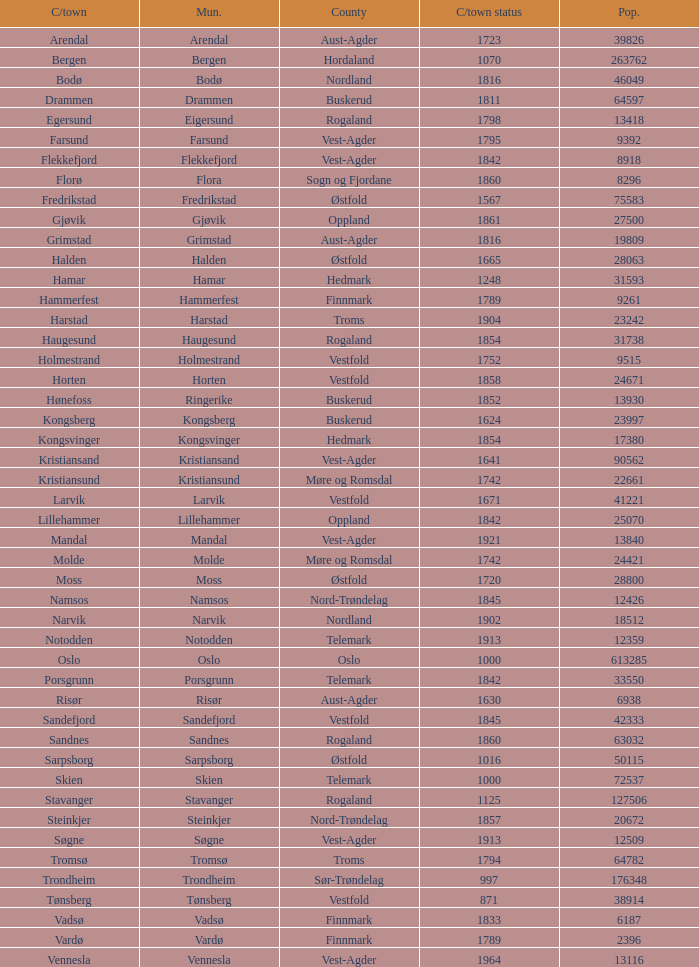What are the cities/towns located in the municipality of Horten? Horten. 